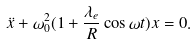Convert formula to latex. <formula><loc_0><loc_0><loc_500><loc_500>\ddot { x } + \omega _ { 0 } ^ { 2 } ( 1 + \frac { \lambda _ { e } } { R } \cos \omega t ) x = 0 .</formula> 